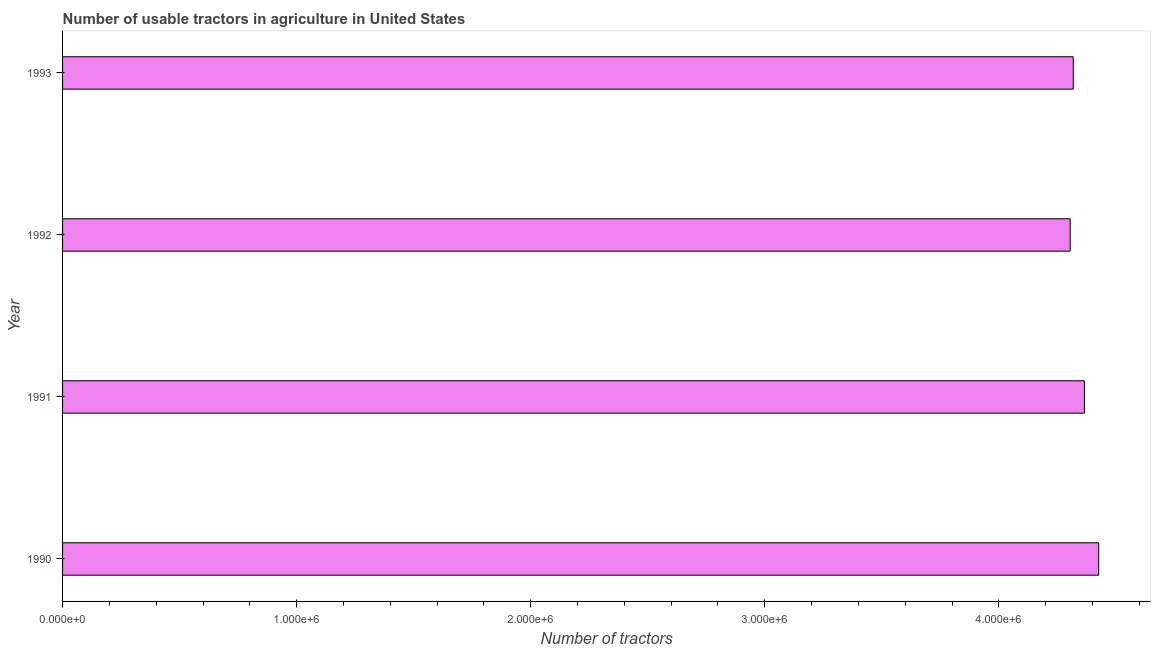Does the graph contain grids?
Your response must be concise. No. What is the title of the graph?
Your answer should be very brief. Number of usable tractors in agriculture in United States. What is the label or title of the X-axis?
Provide a succinct answer. Number of tractors. What is the label or title of the Y-axis?
Provide a succinct answer. Year. What is the number of tractors in 1990?
Provide a short and direct response. 4.43e+06. Across all years, what is the maximum number of tractors?
Give a very brief answer. 4.43e+06. Across all years, what is the minimum number of tractors?
Your answer should be compact. 4.30e+06. In which year was the number of tractors minimum?
Offer a terse response. 1992. What is the sum of the number of tractors?
Provide a short and direct response. 1.74e+07. What is the difference between the number of tractors in 1990 and 1991?
Your answer should be very brief. 6.09e+04. What is the average number of tractors per year?
Your answer should be compact. 4.35e+06. What is the median number of tractors?
Ensure brevity in your answer.  4.34e+06. Is the number of tractors in 1991 less than that in 1992?
Your answer should be compact. No. Is the difference between the number of tractors in 1990 and 1993 greater than the difference between any two years?
Your answer should be very brief. No. What is the difference between the highest and the second highest number of tractors?
Your answer should be compact. 6.09e+04. What is the difference between the highest and the lowest number of tractors?
Keep it short and to the point. 1.22e+05. Are all the bars in the graph horizontal?
Ensure brevity in your answer.  Yes. How many years are there in the graph?
Ensure brevity in your answer.  4. What is the Number of tractors of 1990?
Your response must be concise. 4.43e+06. What is the Number of tractors in 1991?
Keep it short and to the point. 4.37e+06. What is the Number of tractors in 1992?
Make the answer very short. 4.30e+06. What is the Number of tractors in 1993?
Make the answer very short. 4.32e+06. What is the difference between the Number of tractors in 1990 and 1991?
Give a very brief answer. 6.09e+04. What is the difference between the Number of tractors in 1990 and 1992?
Ensure brevity in your answer.  1.22e+05. What is the difference between the Number of tractors in 1990 and 1993?
Your answer should be compact. 1.09e+05. What is the difference between the Number of tractors in 1991 and 1992?
Ensure brevity in your answer.  6.09e+04. What is the difference between the Number of tractors in 1991 and 1993?
Give a very brief answer. 4.78e+04. What is the difference between the Number of tractors in 1992 and 1993?
Your answer should be very brief. -1.31e+04. What is the ratio of the Number of tractors in 1990 to that in 1991?
Offer a terse response. 1.01. What is the ratio of the Number of tractors in 1990 to that in 1992?
Offer a terse response. 1.03. What is the ratio of the Number of tractors in 1990 to that in 1993?
Provide a short and direct response. 1.02. What is the ratio of the Number of tractors in 1991 to that in 1992?
Offer a very short reply. 1.01. 